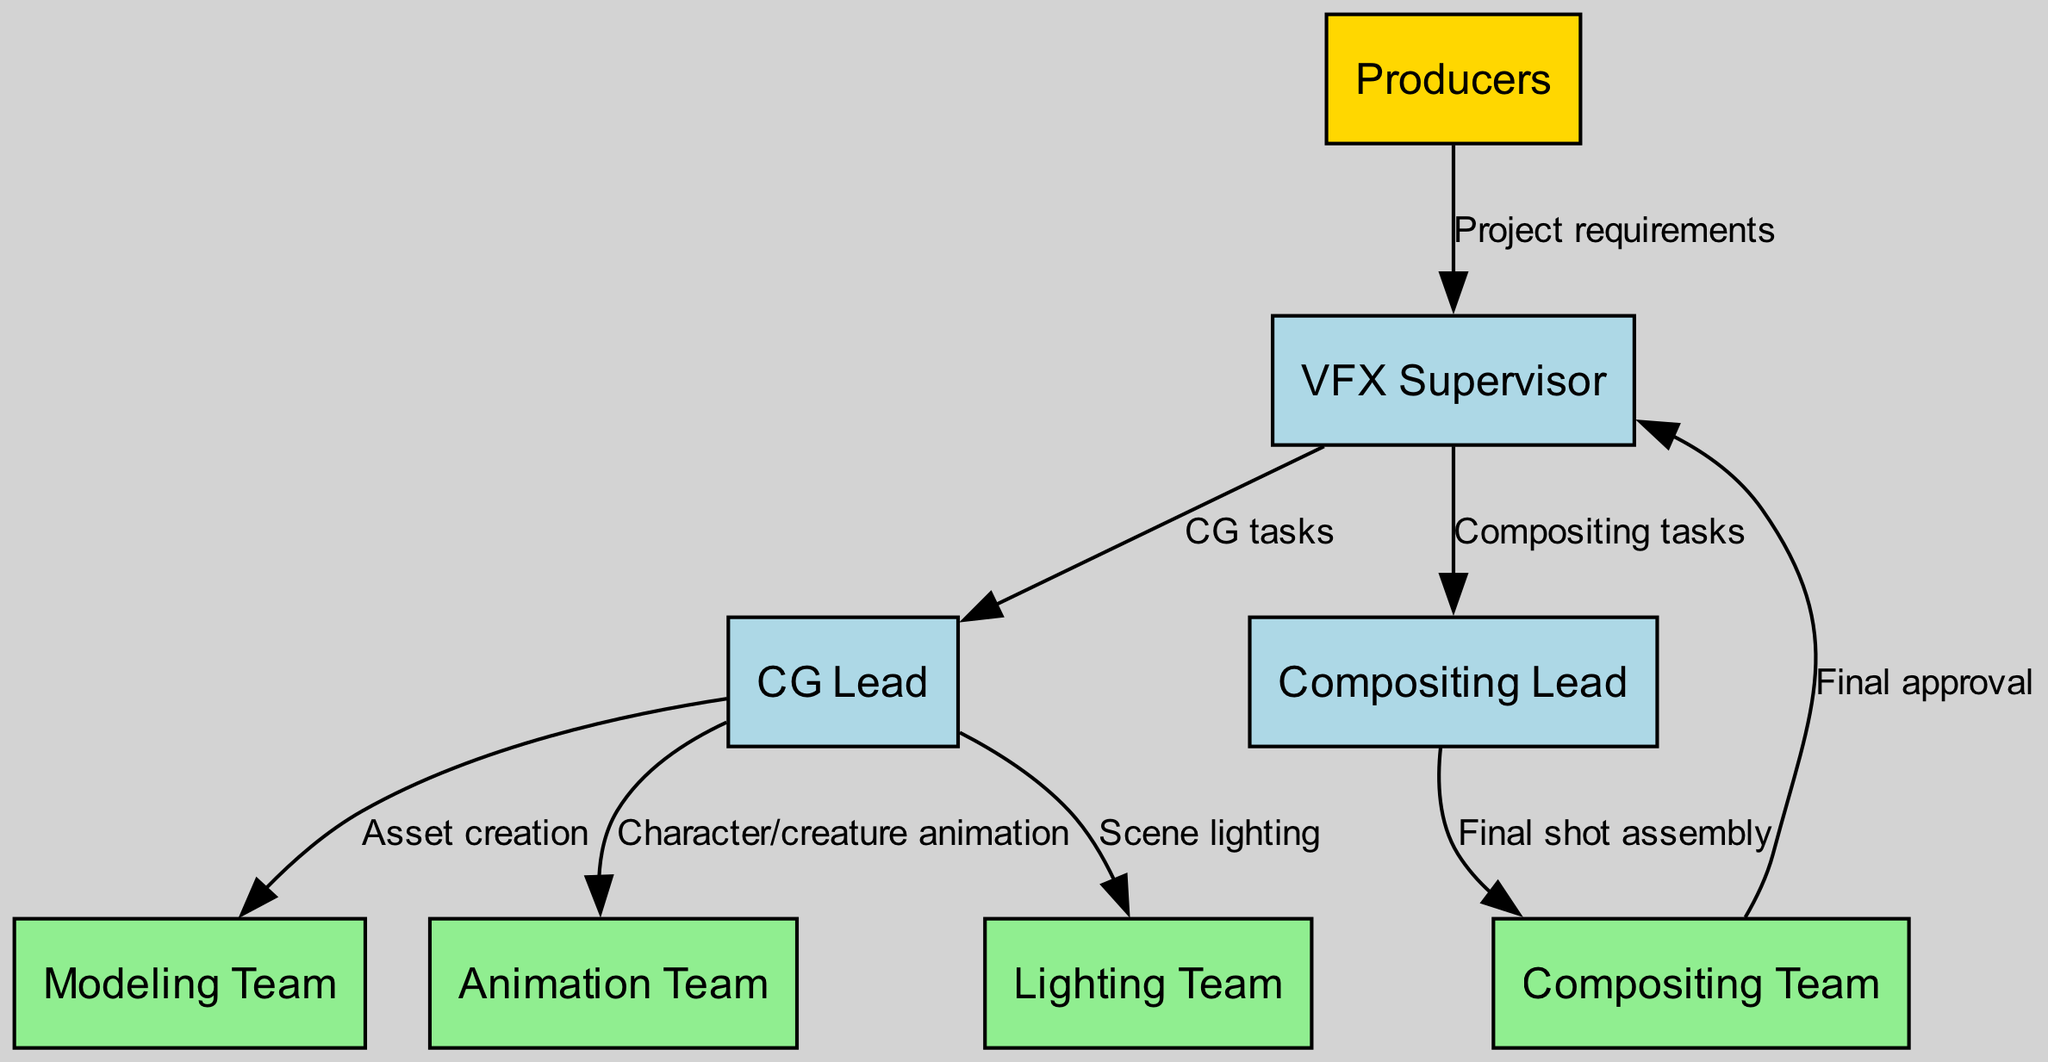What is the role of the node directly above the modeling team? The modeling team node connects directly to the CG lead node, which is positioned above it in the diagram. The CG lead is responsible for overseeing the asset creation tasks assigned to the modeling team.
Answer: CG Lead How many nodes represent teams in the diagram? There are four teams represented: modeling team, animation team, lighting team, and compositing team. Each of these nodes refers to specific functions within the overall VFX process.
Answer: four Which node receives project requirements from the producers? The connection between the producers node and the VFX supervisor node indicates that the VFX supervisor is responsible for receiving the project requirements. This is the first step in the communication flow of the diagram.
Answer: VFX Supervisor What is the relationship between the compositing lead and the compositing team? The relationship is represented by a directed edge that shows the compositing lead assigning tasks for final shot assembly to the compositing team. This action illustrates the hierarchy and task flow within the VFX structure.
Answer: Final shot assembly How many edges in total connect the teams to their leads? The diagram details three teams connected to the CG lead and one team connected to the compositing lead, resulting in a total of four edges representing these connections.
Answer: four Which role approves the final output before it reaches the producers? The final shot assembly performed by the compositing team is then reviewed and approved by the VFX supervisor, who is the last node in the approval chain before reaching the producers. This final verification ensures quality and alignment with project standards.
Answer: VFX Supervisor What type of tasks does the VFX supervisor assign to the compositing lead? The edge from the VFX supervisor to the compositing lead indicates that compositing tasks are assigned, showcasing the supervisor's responsibilities in the workflow of visual effects.
Answer: Compositing tasks Which node is responsible for scene lighting? The CG lead is connected to the lighting team, reflecting that the CG lead is responsible for scene lighting within the visual effects process. This connection illustrates the team's focus on crafting lighting for scenes.
Answer: Lighting Team 